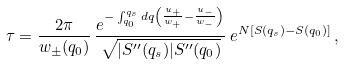<formula> <loc_0><loc_0><loc_500><loc_500>\tau = \frac { 2 \pi } { w _ { \pm } ( q _ { 0 } ) } \, \frac { e ^ { - \int _ { q _ { 0 } } ^ { q _ { s } } d q \left ( \frac { u _ { + } } { w _ { + } } - \frac { u _ { - } } { w _ { - } } \right ) } } { \sqrt { | S ^ { \prime \prime } ( q _ { s } ) | S ^ { \prime \prime } ( q _ { 0 } ) } } \, e ^ { N [ S ( q _ { s } ) - S ( q _ { 0 } ) ] } \, ,</formula> 